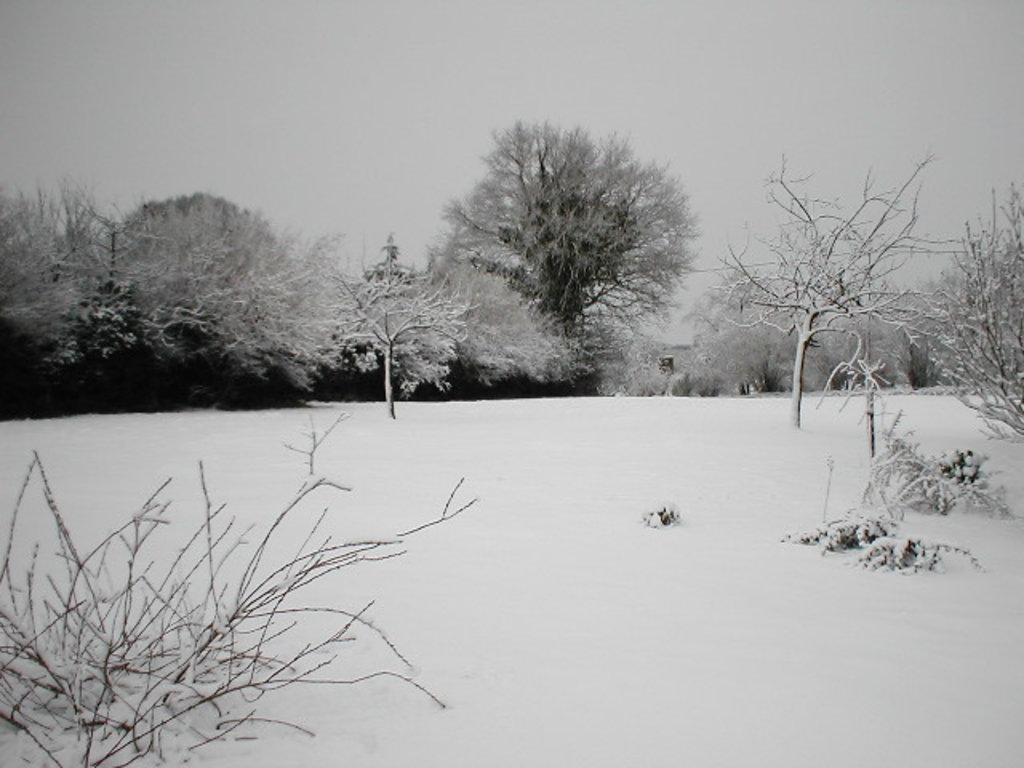What is the condition of the ground in the image? The ground is covered with snow. What can be seen in the background of the image? There are trees in the background of the image. How are the trees affected by the snow? The trees are covered with snow. Can you see any receipts on the ground in the image? There are no receipts visible in the image; the ground is covered with snow. 